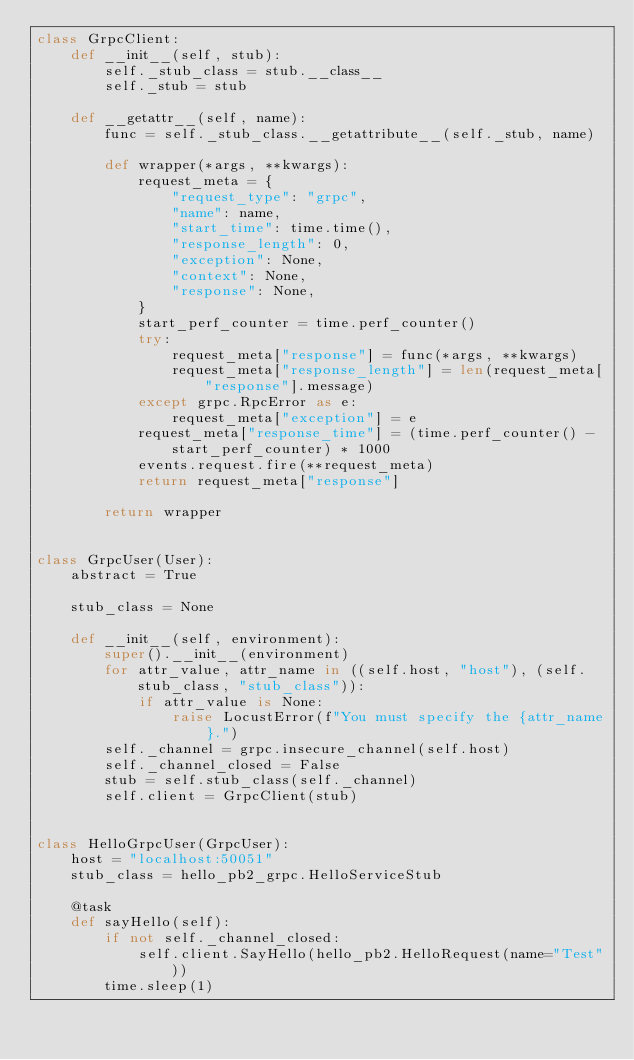Convert code to text. <code><loc_0><loc_0><loc_500><loc_500><_Python_>class GrpcClient:
    def __init__(self, stub):
        self._stub_class = stub.__class__
        self._stub = stub

    def __getattr__(self, name):
        func = self._stub_class.__getattribute__(self._stub, name)

        def wrapper(*args, **kwargs):
            request_meta = {
                "request_type": "grpc",
                "name": name,
                "start_time": time.time(),
                "response_length": 0,
                "exception": None,
                "context": None,
                "response": None,
            }
            start_perf_counter = time.perf_counter()
            try:
                request_meta["response"] = func(*args, **kwargs)
                request_meta["response_length"] = len(request_meta["response"].message)
            except grpc.RpcError as e:
                request_meta["exception"] = e
            request_meta["response_time"] = (time.perf_counter() - start_perf_counter) * 1000
            events.request.fire(**request_meta)
            return request_meta["response"]

        return wrapper


class GrpcUser(User):
    abstract = True

    stub_class = None

    def __init__(self, environment):
        super().__init__(environment)
        for attr_value, attr_name in ((self.host, "host"), (self.stub_class, "stub_class")):
            if attr_value is None:
                raise LocustError(f"You must specify the {attr_name}.")
        self._channel = grpc.insecure_channel(self.host)
        self._channel_closed = False
        stub = self.stub_class(self._channel)
        self.client = GrpcClient(stub)


class HelloGrpcUser(GrpcUser):
    host = "localhost:50051"
    stub_class = hello_pb2_grpc.HelloServiceStub

    @task
    def sayHello(self):
        if not self._channel_closed:
            self.client.SayHello(hello_pb2.HelloRequest(name="Test"))
        time.sleep(1)
</code> 